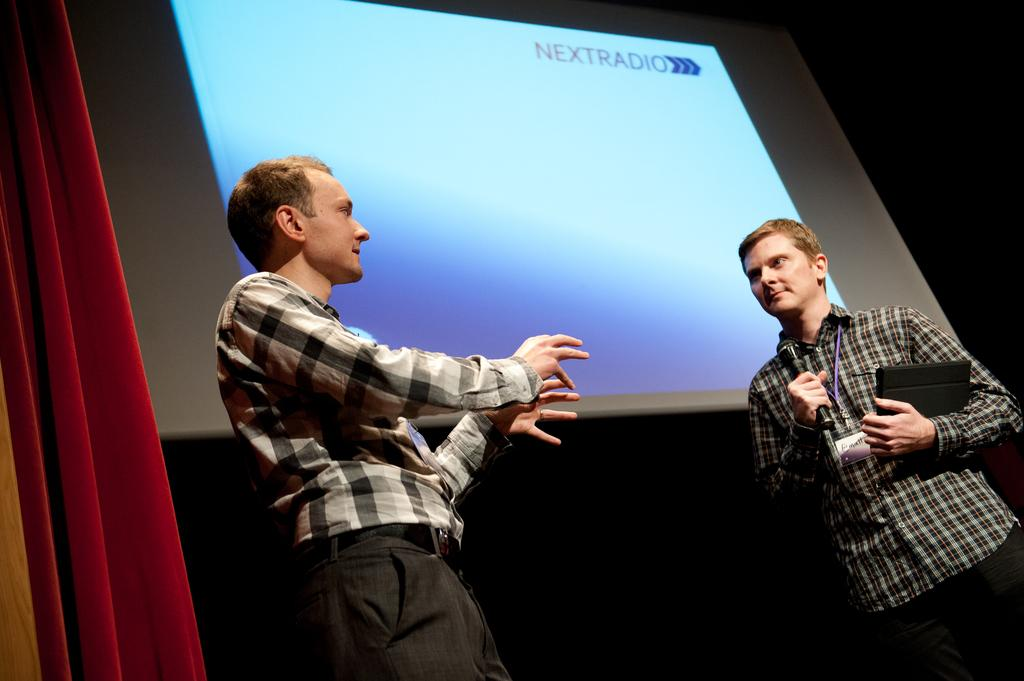What is the main object in the image? There is a screen in the image. How many people are present in the image? There are two people in the image. What can be seen in the background of the image? There is a curtain in the image. What are the people holding in the image? One person is holding a tablet, and the other person is holding a mic. What type of metal is being kicked by one of the people in the image? There is no metal or kicking activity present in the image. 